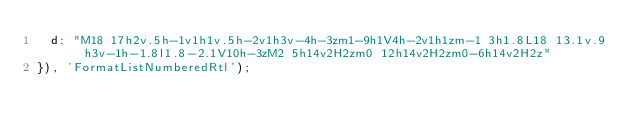<code> <loc_0><loc_0><loc_500><loc_500><_JavaScript_>  d: "M18 17h2v.5h-1v1h1v.5h-2v1h3v-4h-3zm1-9h1V4h-2v1h1zm-1 3h1.8L18 13.1v.9h3v-1h-1.8l1.8-2.1V10h-3zM2 5h14v2H2zm0 12h14v2H2zm0-6h14v2H2z"
}), 'FormatListNumberedRtl');</code> 